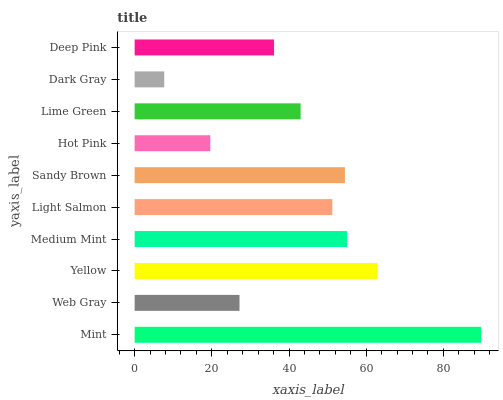Is Dark Gray the minimum?
Answer yes or no. Yes. Is Mint the maximum?
Answer yes or no. Yes. Is Web Gray the minimum?
Answer yes or no. No. Is Web Gray the maximum?
Answer yes or no. No. Is Mint greater than Web Gray?
Answer yes or no. Yes. Is Web Gray less than Mint?
Answer yes or no. Yes. Is Web Gray greater than Mint?
Answer yes or no. No. Is Mint less than Web Gray?
Answer yes or no. No. Is Light Salmon the high median?
Answer yes or no. Yes. Is Lime Green the low median?
Answer yes or no. Yes. Is Mint the high median?
Answer yes or no. No. Is Mint the low median?
Answer yes or no. No. 